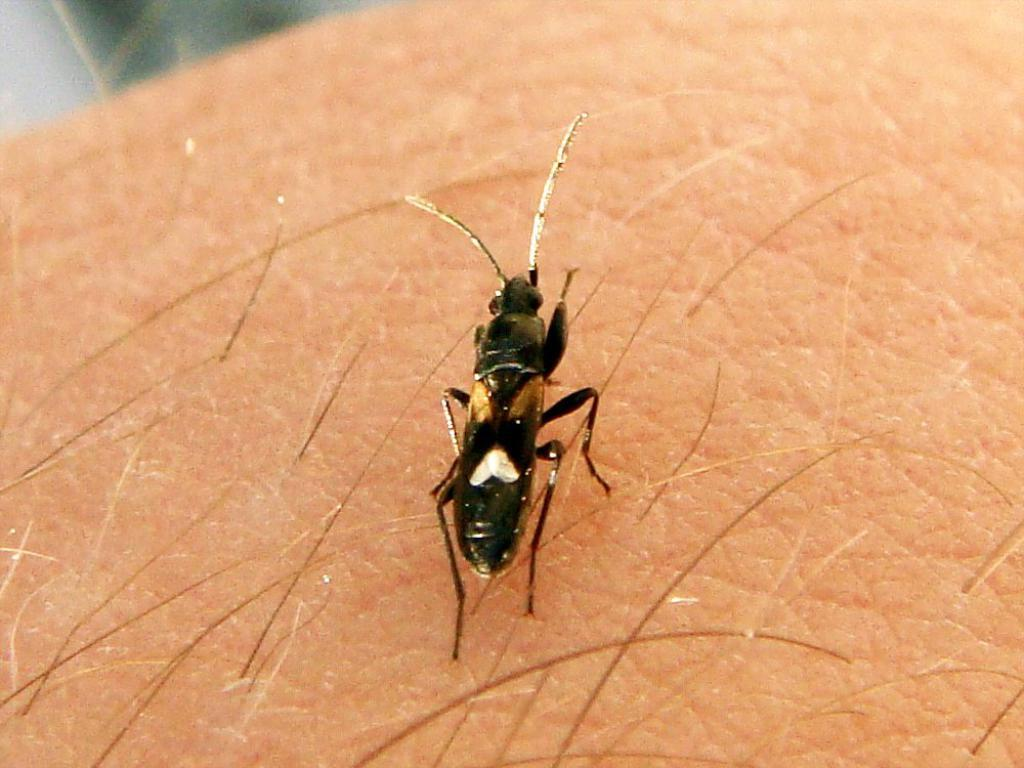What is the main subject of the image? There is an insect in the image. Where is the insect located in the image? The insect is in the center of the image. What color is the insect? The insect is black in color. What type of pump can be seen in the image? There is no pump present in the image; it features an insect. How does the brake work in the image? There is no brake present in the image, as it features an insect. 